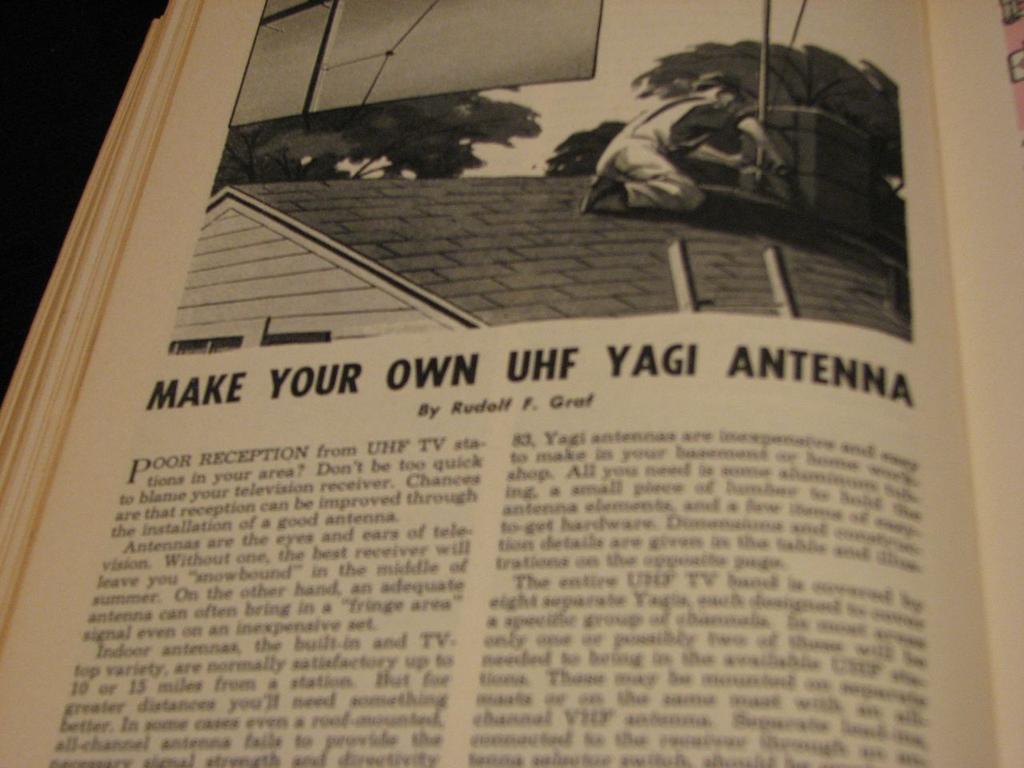What is the title of the text?
Offer a terse response. Make your own uhf yagi antenna. 